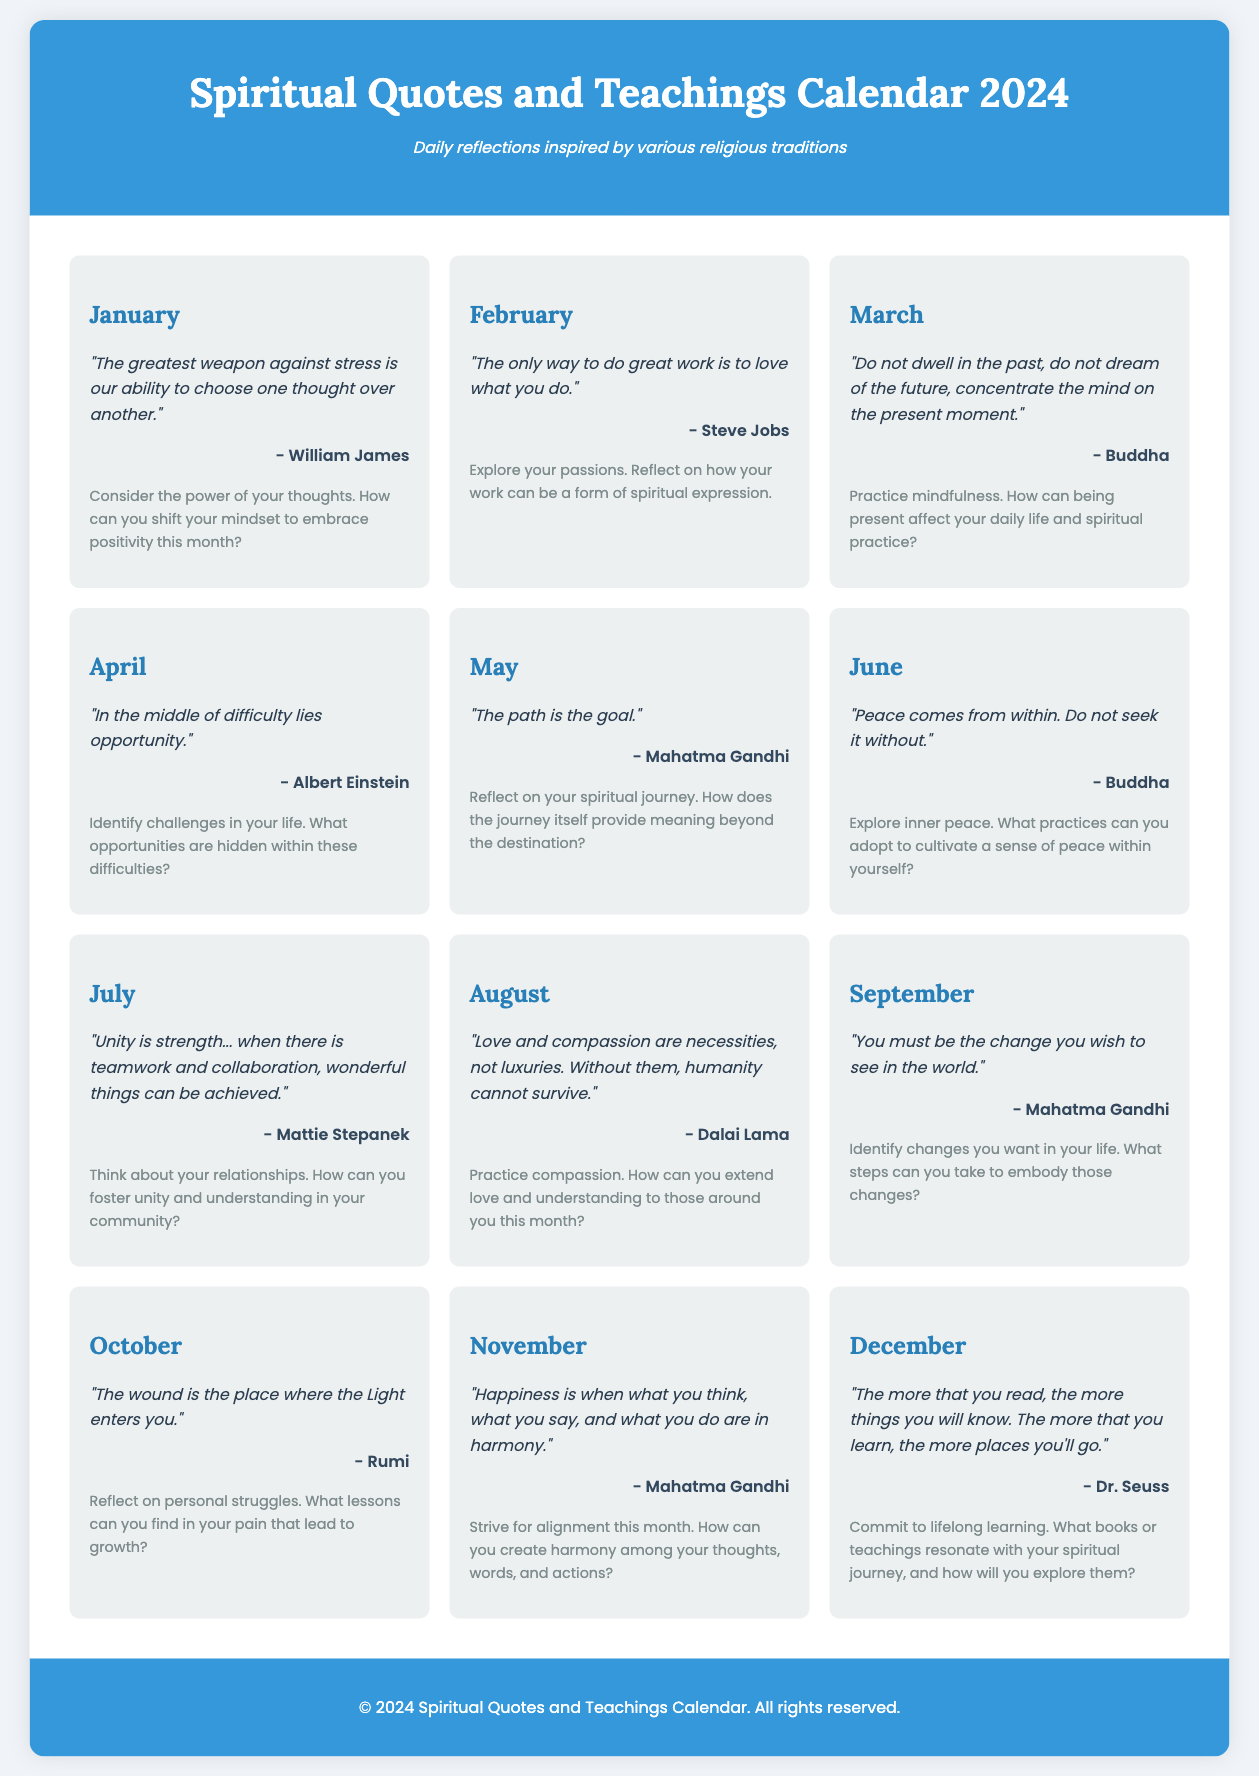What is the title of the document? The title of the document is presented in the header section of the rendered page.
Answer: Spiritual Quotes and Teachings Calendar 2024 How many months are included in the calendar? The document lists a quote and reflection for each month from January to December, indicating a total of 12 months.
Answer: 12 Who is the author of the quote for June? The author of the quote for June is mentioned directly below the quote text for that month.
Answer: Buddha What is the theme of the reflection for August? The reflection for August focuses on compassion and extending love to those around you, as stated in the reflection text.
Answer: Practice compassion Which month features the quote, "In the middle of difficulty lies opportunity"? The specific month where this quote appears is indicated under the related month card in the document.
Answer: April What is the main idea of the quote for March? The quote for March speaks about concentration on the present moment, which can be inferred from its wording.
Answer: Mindfulness How many reflections are inspired by Mahatma Gandhi? By counting the months where his quotes appear, we can determine the total number of reflections inspired by him.
Answer: 3 What color is used for the footer background? The background color for the footer is specified in the styling section of the document.
Answer: #3498db 